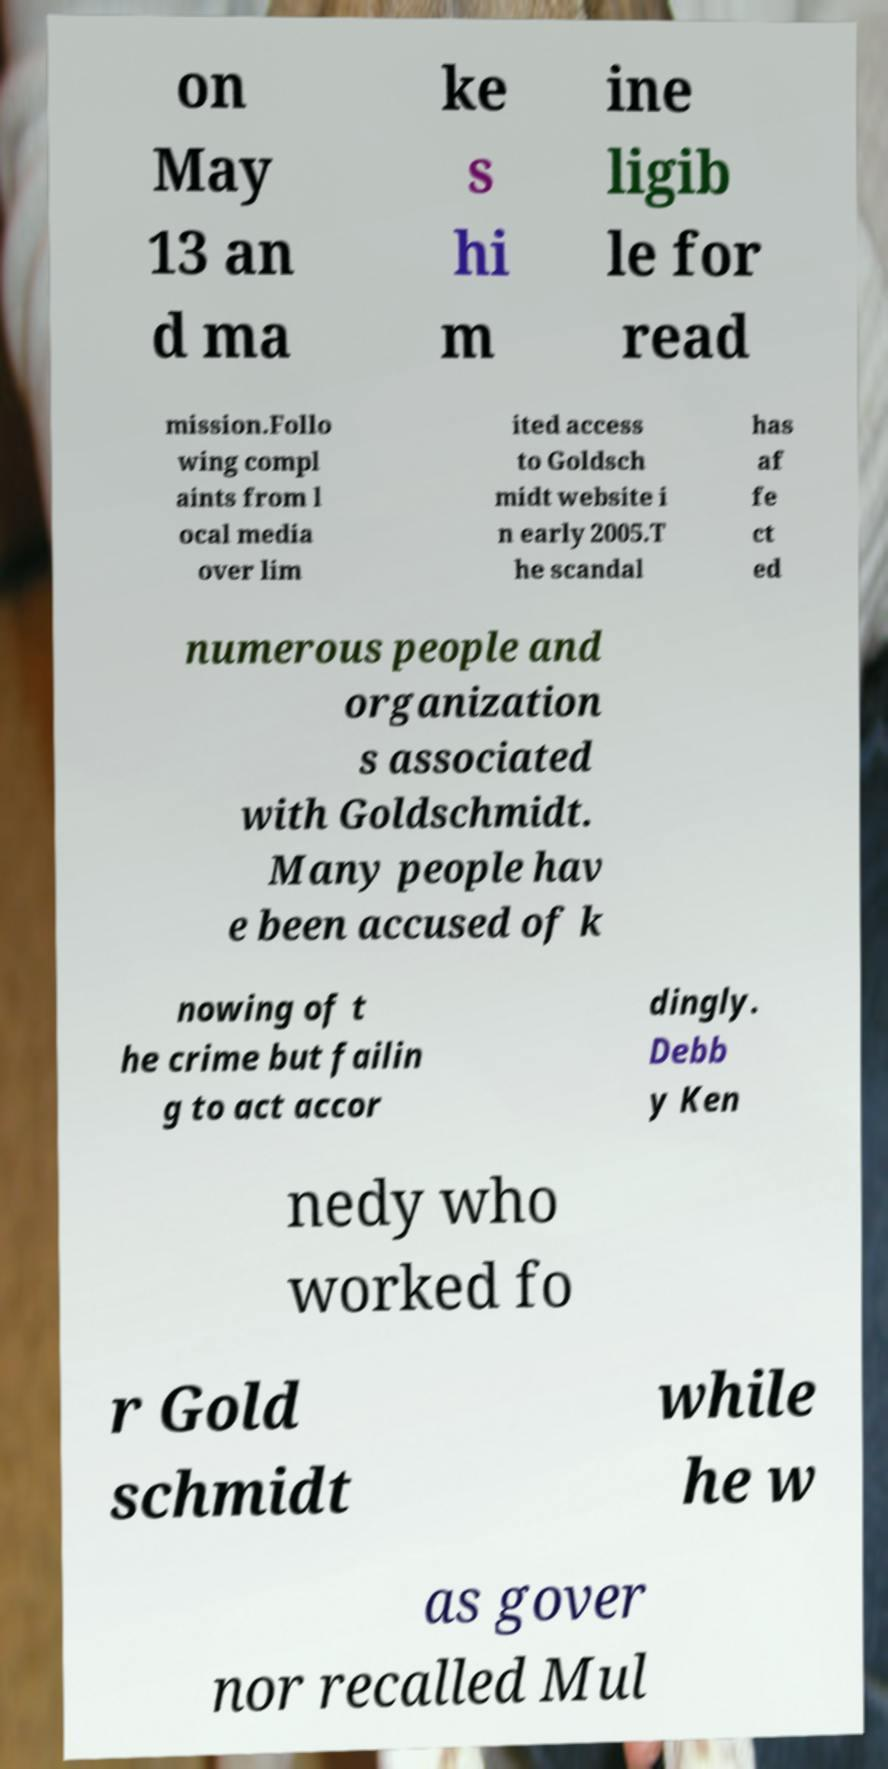Can you read and provide the text displayed in the image?This photo seems to have some interesting text. Can you extract and type it out for me? on May 13 an d ma ke s hi m ine ligib le for read mission.Follo wing compl aints from l ocal media over lim ited access to Goldsch midt website i n early 2005.T he scandal has af fe ct ed numerous people and organization s associated with Goldschmidt. Many people hav e been accused of k nowing of t he crime but failin g to act accor dingly. Debb y Ken nedy who worked fo r Gold schmidt while he w as gover nor recalled Mul 